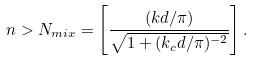<formula> <loc_0><loc_0><loc_500><loc_500>n > N _ { m i x } = \left [ \frac { ( k d / \pi ) } { \sqrt { 1 + ( k _ { c } d / \pi ) ^ { - 2 } } } \right ] .</formula> 